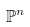<formula> <loc_0><loc_0><loc_500><loc_500>\mathbb { P } ^ { n }</formula> 